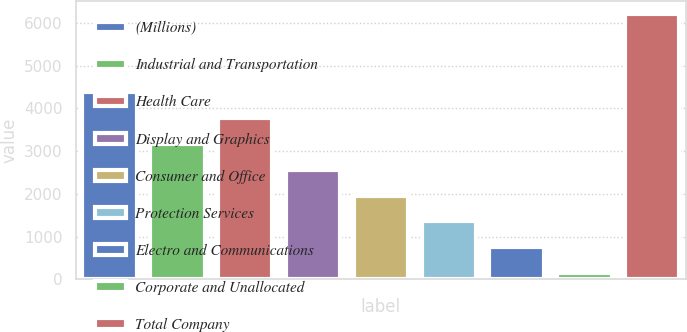Convert chart. <chart><loc_0><loc_0><loc_500><loc_500><bar_chart><fcel>(Millions)<fcel>Industrial and Transportation<fcel>Health Care<fcel>Display and Graphics<fcel>Consumer and Office<fcel>Protection Services<fcel>Electro and Communications<fcel>Corporate and Unallocated<fcel>Total Company<nl><fcel>4378.3<fcel>3168.5<fcel>3773.4<fcel>2563.6<fcel>1958.7<fcel>1353.8<fcel>748.9<fcel>144<fcel>6193<nl></chart> 